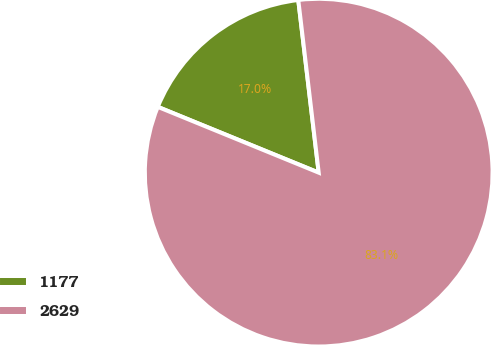Convert chart. <chart><loc_0><loc_0><loc_500><loc_500><pie_chart><fcel>1177<fcel>2629<nl><fcel>16.95%<fcel>83.05%<nl></chart> 